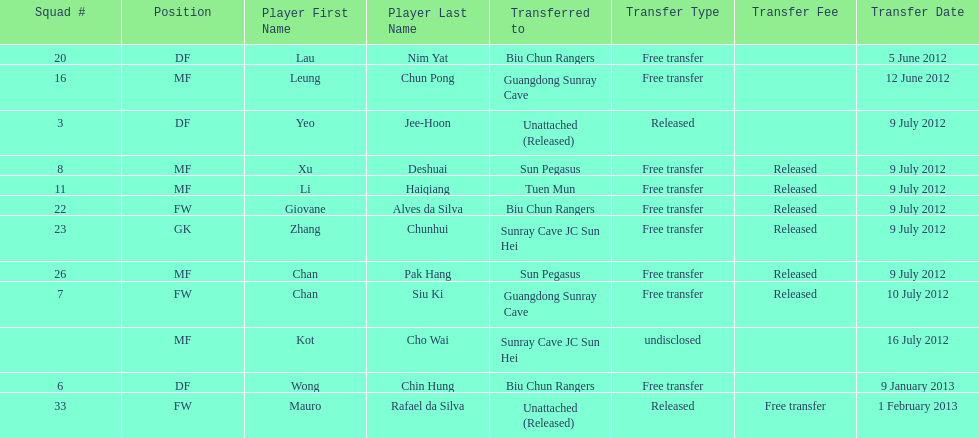Player transferred immediately before mauro rafael da silva Wong Chin Hung. I'm looking to parse the entire table for insights. Could you assist me with that? {'header': ['Squad #', 'Position', 'Player First Name', 'Player Last Name', 'Transferred to', 'Transfer Type', 'Transfer Fee', 'Transfer Date'], 'rows': [['20', 'DF', 'Lau', 'Nim Yat', 'Biu Chun Rangers', 'Free transfer', '', '5 June 2012'], ['16', 'MF', 'Leung', 'Chun Pong', 'Guangdong Sunray Cave', 'Free transfer', '', '12 June 2012'], ['3', 'DF', 'Yeo', 'Jee-Hoon', 'Unattached (Released)', 'Released', '', '9 July 2012'], ['8', 'MF', 'Xu', 'Deshuai', 'Sun Pegasus', 'Free transfer', 'Released', '9 July 2012'], ['11', 'MF', 'Li', 'Haiqiang', 'Tuen Mun', 'Free transfer', 'Released', '9 July 2012'], ['22', 'FW', 'Giovane', 'Alves da Silva', 'Biu Chun Rangers', 'Free transfer', 'Released', '9 July 2012'], ['23', 'GK', 'Zhang', 'Chunhui', 'Sunray Cave JC Sun Hei', 'Free transfer', 'Released', '9 July 2012'], ['26', 'MF', 'Chan', 'Pak Hang', 'Sun Pegasus', 'Free transfer', 'Released', '9 July 2012'], ['7', 'FW', 'Chan', 'Siu Ki', 'Guangdong Sunray Cave', 'Free transfer', 'Released', '10 July 2012'], ['', 'MF', 'Kot', 'Cho Wai', 'Sunray Cave JC Sun Hei', 'undisclosed', '', '16 July 2012'], ['6', 'DF', 'Wong', 'Chin Hung', 'Biu Chun Rangers', 'Free transfer', '', '9 January 2013'], ['33', 'FW', 'Mauro', 'Rafael da Silva', 'Unattached (Released)', 'Released', 'Free transfer', '1 February 2013']]} 